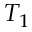Convert formula to latex. <formula><loc_0><loc_0><loc_500><loc_500>T _ { 1 }</formula> 